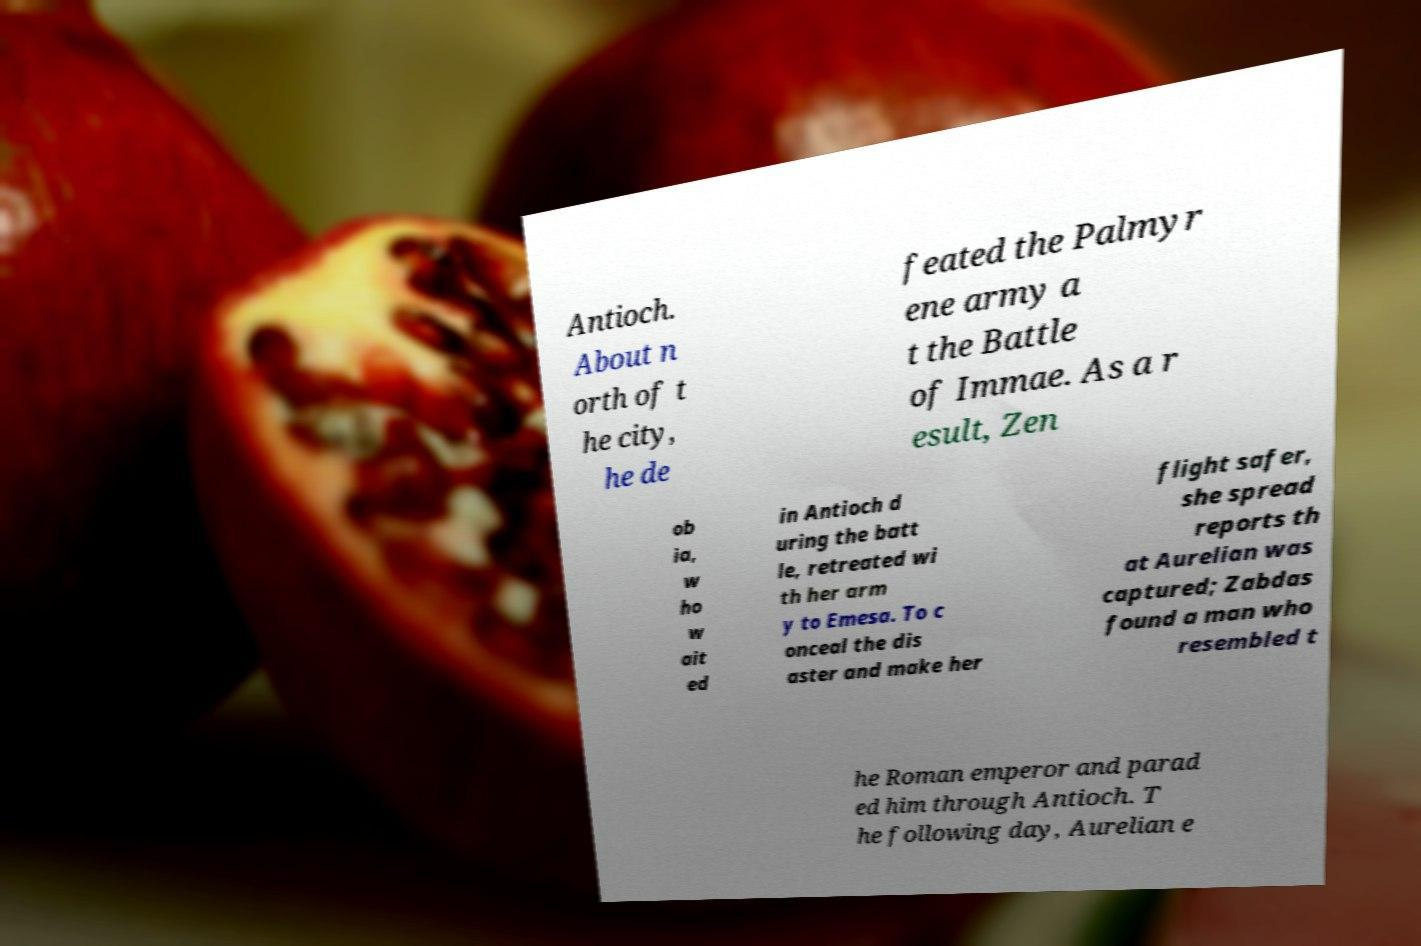There's text embedded in this image that I need extracted. Can you transcribe it verbatim? Antioch. About n orth of t he city, he de feated the Palmyr ene army a t the Battle of Immae. As a r esult, Zen ob ia, w ho w ait ed in Antioch d uring the batt le, retreated wi th her arm y to Emesa. To c onceal the dis aster and make her flight safer, she spread reports th at Aurelian was captured; Zabdas found a man who resembled t he Roman emperor and parad ed him through Antioch. T he following day, Aurelian e 